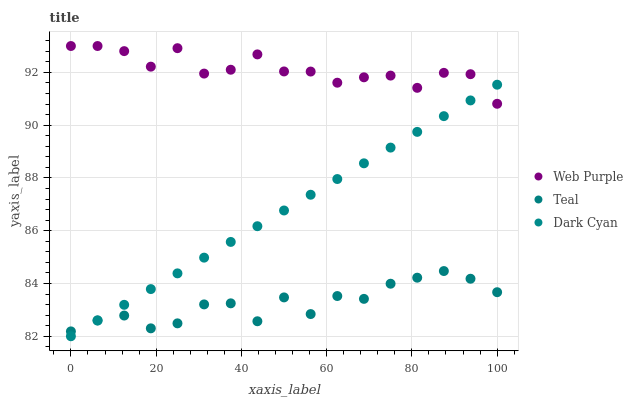Does Teal have the minimum area under the curve?
Answer yes or no. Yes. Does Web Purple have the maximum area under the curve?
Answer yes or no. Yes. Does Web Purple have the minimum area under the curve?
Answer yes or no. No. Does Teal have the maximum area under the curve?
Answer yes or no. No. Is Dark Cyan the smoothest?
Answer yes or no. Yes. Is Web Purple the roughest?
Answer yes or no. Yes. Is Teal the smoothest?
Answer yes or no. No. Is Teal the roughest?
Answer yes or no. No. Does Dark Cyan have the lowest value?
Answer yes or no. Yes. Does Teal have the lowest value?
Answer yes or no. No. Does Web Purple have the highest value?
Answer yes or no. Yes. Does Teal have the highest value?
Answer yes or no. No. Is Teal less than Web Purple?
Answer yes or no. Yes. Is Web Purple greater than Teal?
Answer yes or no. Yes. Does Web Purple intersect Dark Cyan?
Answer yes or no. Yes. Is Web Purple less than Dark Cyan?
Answer yes or no. No. Is Web Purple greater than Dark Cyan?
Answer yes or no. No. Does Teal intersect Web Purple?
Answer yes or no. No. 